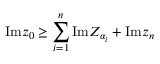<formula> <loc_0><loc_0><loc_500><loc_500>I m z _ { 0 } \geq \sum _ { i = 1 } ^ { n } I m Z _ { \alpha _ { i } } + I m z _ { n }</formula> 